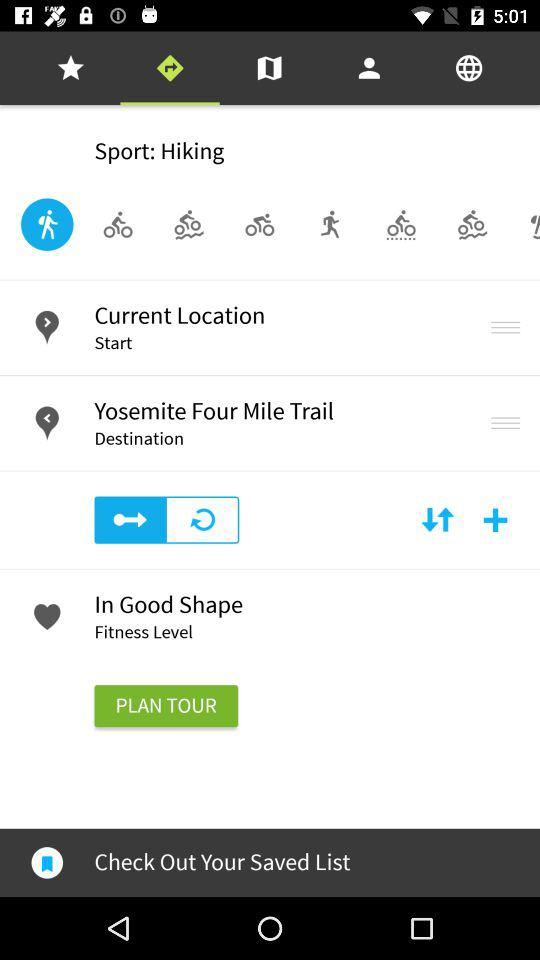What is the destination? The destination is "Yosemite Four Mile Trail". 